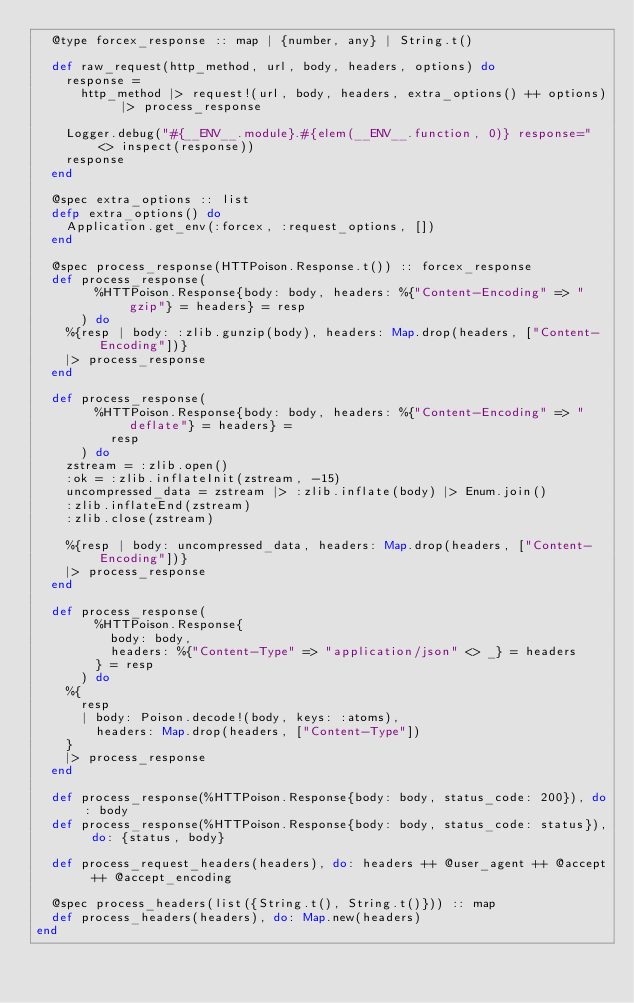Convert code to text. <code><loc_0><loc_0><loc_500><loc_500><_Elixir_>  @type forcex_response :: map | {number, any} | String.t()

  def raw_request(http_method, url, body, headers, options) do
    response =
      http_method |> request!(url, body, headers, extra_options() ++ options) |> process_response

    Logger.debug("#{__ENV__.module}.#{elem(__ENV__.function, 0)} response=" <> inspect(response))
    response
  end

  @spec extra_options :: list
  defp extra_options() do
    Application.get_env(:forcex, :request_options, [])
  end

  @spec process_response(HTTPoison.Response.t()) :: forcex_response
  def process_response(
        %HTTPoison.Response{body: body, headers: %{"Content-Encoding" => "gzip"} = headers} = resp
      ) do
    %{resp | body: :zlib.gunzip(body), headers: Map.drop(headers, ["Content-Encoding"])}
    |> process_response
  end

  def process_response(
        %HTTPoison.Response{body: body, headers: %{"Content-Encoding" => "deflate"} = headers} =
          resp
      ) do
    zstream = :zlib.open()
    :ok = :zlib.inflateInit(zstream, -15)
    uncompressed_data = zstream |> :zlib.inflate(body) |> Enum.join()
    :zlib.inflateEnd(zstream)
    :zlib.close(zstream)

    %{resp | body: uncompressed_data, headers: Map.drop(headers, ["Content-Encoding"])}
    |> process_response
  end

  def process_response(
        %HTTPoison.Response{
          body: body,
          headers: %{"Content-Type" => "application/json" <> _} = headers
        } = resp
      ) do
    %{
      resp
      | body: Poison.decode!(body, keys: :atoms),
        headers: Map.drop(headers, ["Content-Type"])
    }
    |> process_response
  end

  def process_response(%HTTPoison.Response{body: body, status_code: 200}), do: body
  def process_response(%HTTPoison.Response{body: body, status_code: status}), do: {status, body}

  def process_request_headers(headers), do: headers ++ @user_agent ++ @accept ++ @accept_encoding

  @spec process_headers(list({String.t(), String.t()})) :: map
  def process_headers(headers), do: Map.new(headers)
end
</code> 